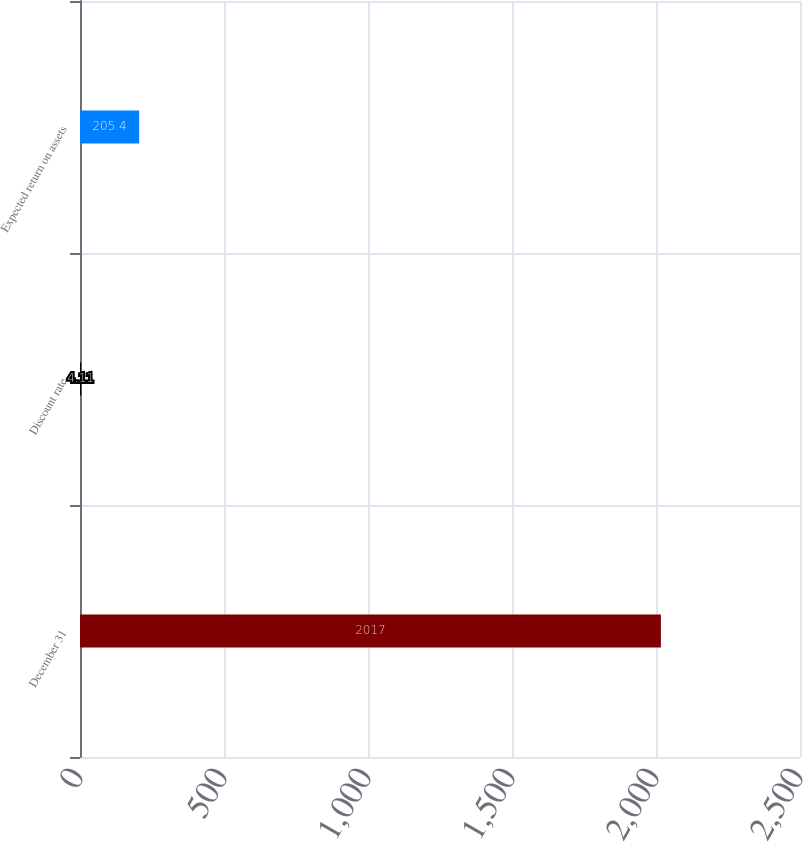Convert chart to OTSL. <chart><loc_0><loc_0><loc_500><loc_500><bar_chart><fcel>December 31<fcel>Discount rate<fcel>Expected return on assets<nl><fcel>2017<fcel>4.11<fcel>205.4<nl></chart> 